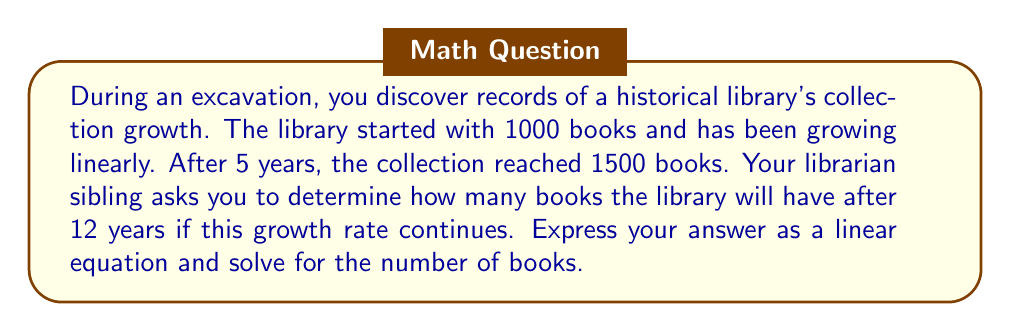Teach me how to tackle this problem. Let's approach this step-by-step:

1) First, we need to find the rate of growth per year. We can do this using the slope formula:

   $$ \text{Rate} = \frac{\text{Change in books}}{\text{Change in time}} = \frac{1500 - 1000}{5 - 0} = \frac{500}{5} = 100 \text{ books/year} $$

2) Now we can form a linear equation. Let $y$ be the number of books and $x$ be the number of years:

   $$ y = 100x + 1000 $$

   Where 100 is the rate of growth per year, and 1000 is the initial number of books.

3) To find the number of books after 12 years, we substitute $x = 12$ into our equation:

   $$ y = 100(12) + 1000 $$
   $$ y = 1200 + 1000 $$
   $$ y = 2200 $$

Therefore, after 12 years, the library will have 2200 books.
Answer: $y = 100x + 1000$; 2200 books 